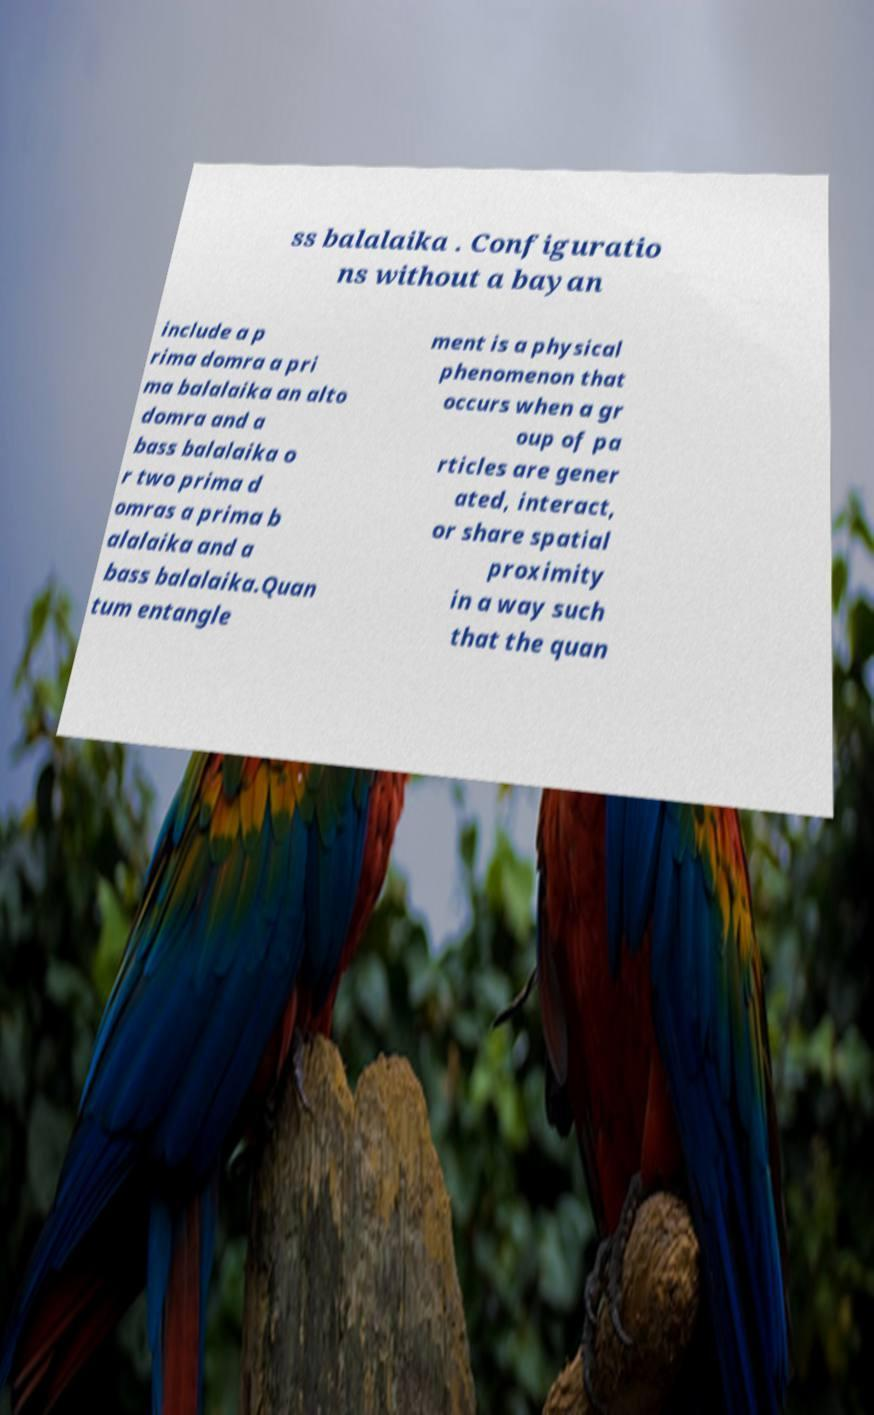Please identify and transcribe the text found in this image. ss balalaika . Configuratio ns without a bayan include a p rima domra a pri ma balalaika an alto domra and a bass balalaika o r two prima d omras a prima b alalaika and a bass balalaika.Quan tum entangle ment is a physical phenomenon that occurs when a gr oup of pa rticles are gener ated, interact, or share spatial proximity in a way such that the quan 